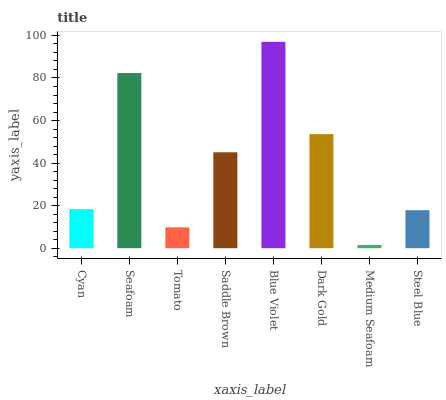Is Medium Seafoam the minimum?
Answer yes or no. Yes. Is Blue Violet the maximum?
Answer yes or no. Yes. Is Seafoam the minimum?
Answer yes or no. No. Is Seafoam the maximum?
Answer yes or no. No. Is Seafoam greater than Cyan?
Answer yes or no. Yes. Is Cyan less than Seafoam?
Answer yes or no. Yes. Is Cyan greater than Seafoam?
Answer yes or no. No. Is Seafoam less than Cyan?
Answer yes or no. No. Is Saddle Brown the high median?
Answer yes or no. Yes. Is Cyan the low median?
Answer yes or no. Yes. Is Tomato the high median?
Answer yes or no. No. Is Dark Gold the low median?
Answer yes or no. No. 